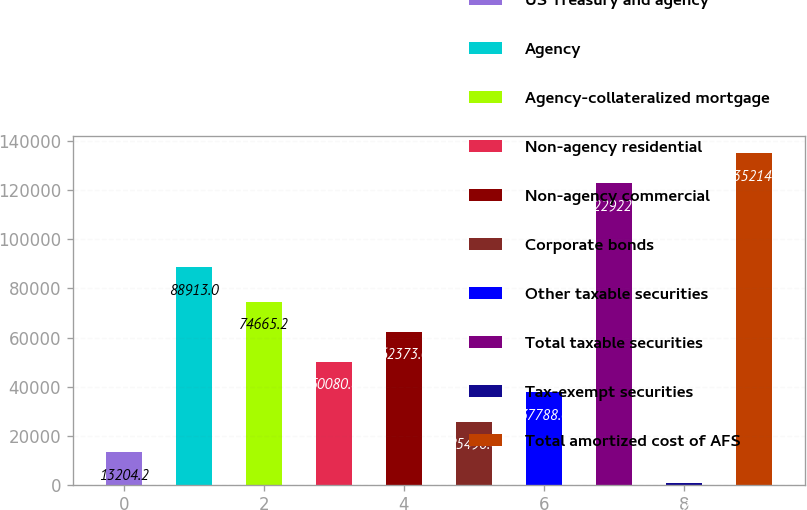<chart> <loc_0><loc_0><loc_500><loc_500><bar_chart><fcel>US Treasury and agency<fcel>Agency<fcel>Agency-collateralized mortgage<fcel>Non-agency residential<fcel>Non-agency commercial<fcel>Corporate bonds<fcel>Other taxable securities<fcel>Total taxable securities<fcel>Tax-exempt securities<fcel>Total amortized cost of AFS<nl><fcel>13204.2<fcel>88913<fcel>74665.2<fcel>50080.8<fcel>62373<fcel>25496.4<fcel>37788.6<fcel>122922<fcel>912<fcel>135214<nl></chart> 